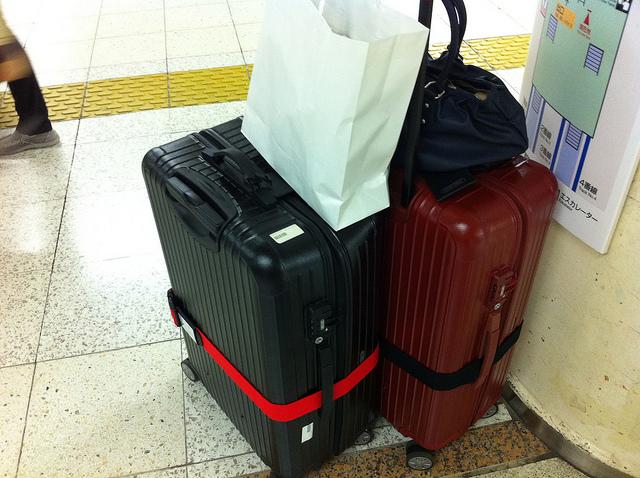Where is the red strap?
Be succinct. Around suitcase. How many red bags are in the picture?
Short answer required. 1. Are those hard shell suitcases?
Quick response, please. Yes. Which color are the suitcases?
Give a very brief answer. Red and black. 